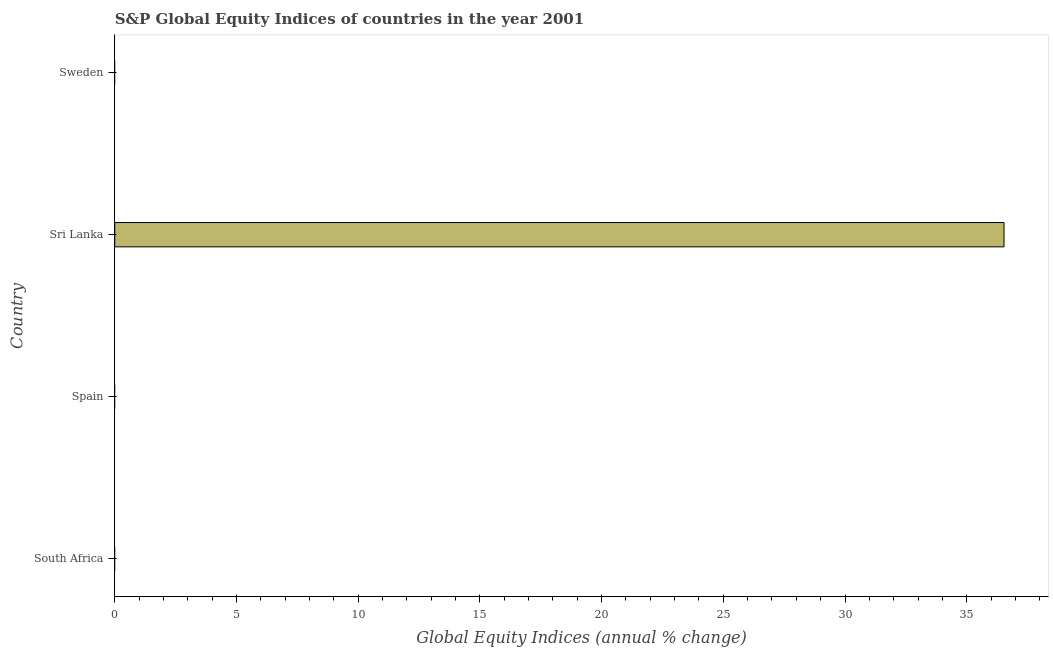Does the graph contain grids?
Keep it short and to the point. No. What is the title of the graph?
Provide a short and direct response. S&P Global Equity Indices of countries in the year 2001. What is the label or title of the X-axis?
Give a very brief answer. Global Equity Indices (annual % change). Across all countries, what is the maximum s&p global equity indices?
Make the answer very short. 36.53. In which country was the s&p global equity indices maximum?
Your response must be concise. Sri Lanka. What is the sum of the s&p global equity indices?
Offer a terse response. 36.53. What is the average s&p global equity indices per country?
Your answer should be very brief. 9.13. In how many countries, is the s&p global equity indices greater than 33 %?
Ensure brevity in your answer.  1. What is the difference between the highest and the lowest s&p global equity indices?
Offer a very short reply. 36.53. In how many countries, is the s&p global equity indices greater than the average s&p global equity indices taken over all countries?
Ensure brevity in your answer.  1. How many bars are there?
Ensure brevity in your answer.  1. How many countries are there in the graph?
Your response must be concise. 4. Are the values on the major ticks of X-axis written in scientific E-notation?
Offer a very short reply. No. What is the Global Equity Indices (annual % change) of Spain?
Provide a short and direct response. 0. What is the Global Equity Indices (annual % change) of Sri Lanka?
Provide a short and direct response. 36.53. What is the Global Equity Indices (annual % change) in Sweden?
Make the answer very short. 0. 